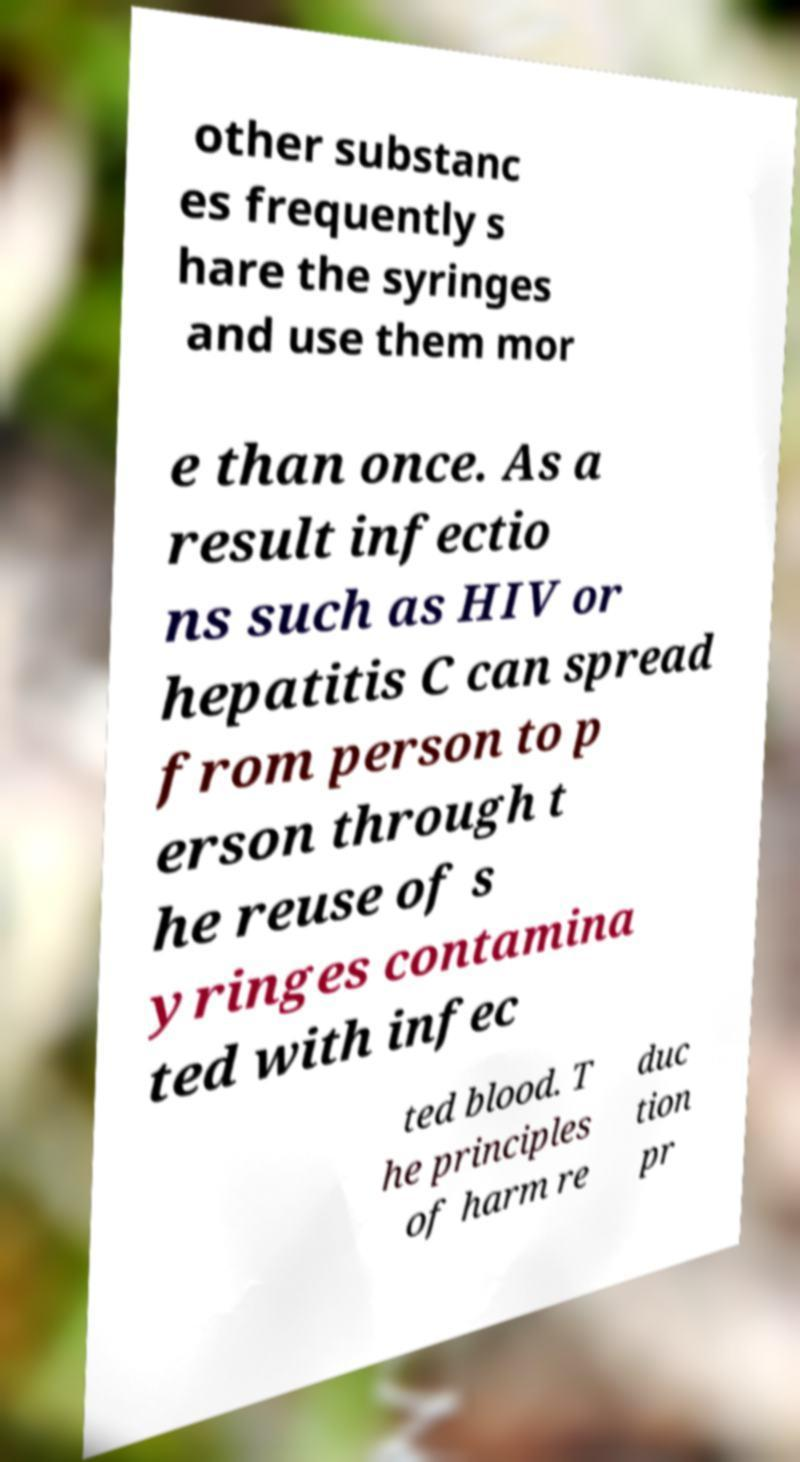Can you accurately transcribe the text from the provided image for me? other substanc es frequently s hare the syringes and use them mor e than once. As a result infectio ns such as HIV or hepatitis C can spread from person to p erson through t he reuse of s yringes contamina ted with infec ted blood. T he principles of harm re duc tion pr 